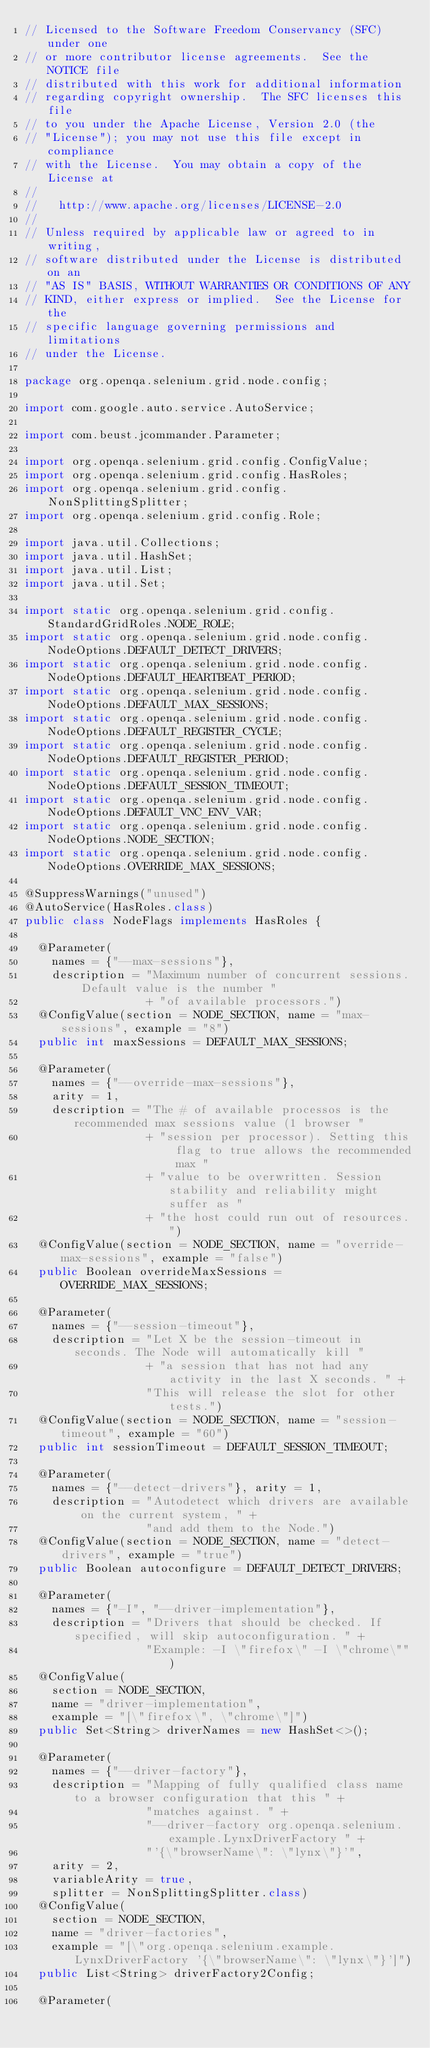Convert code to text. <code><loc_0><loc_0><loc_500><loc_500><_Java_>// Licensed to the Software Freedom Conservancy (SFC) under one
// or more contributor license agreements.  See the NOTICE file
// distributed with this work for additional information
// regarding copyright ownership.  The SFC licenses this file
// to you under the Apache License, Version 2.0 (the
// "License"); you may not use this file except in compliance
// with the License.  You may obtain a copy of the License at
//
//   http://www.apache.org/licenses/LICENSE-2.0
//
// Unless required by applicable law or agreed to in writing,
// software distributed under the License is distributed on an
// "AS IS" BASIS, WITHOUT WARRANTIES OR CONDITIONS OF ANY
// KIND, either express or implied.  See the License for the
// specific language governing permissions and limitations
// under the License.

package org.openqa.selenium.grid.node.config;

import com.google.auto.service.AutoService;

import com.beust.jcommander.Parameter;

import org.openqa.selenium.grid.config.ConfigValue;
import org.openqa.selenium.grid.config.HasRoles;
import org.openqa.selenium.grid.config.NonSplittingSplitter;
import org.openqa.selenium.grid.config.Role;

import java.util.Collections;
import java.util.HashSet;
import java.util.List;
import java.util.Set;

import static org.openqa.selenium.grid.config.StandardGridRoles.NODE_ROLE;
import static org.openqa.selenium.grid.node.config.NodeOptions.DEFAULT_DETECT_DRIVERS;
import static org.openqa.selenium.grid.node.config.NodeOptions.DEFAULT_HEARTBEAT_PERIOD;
import static org.openqa.selenium.grid.node.config.NodeOptions.DEFAULT_MAX_SESSIONS;
import static org.openqa.selenium.grid.node.config.NodeOptions.DEFAULT_REGISTER_CYCLE;
import static org.openqa.selenium.grid.node.config.NodeOptions.DEFAULT_REGISTER_PERIOD;
import static org.openqa.selenium.grid.node.config.NodeOptions.DEFAULT_SESSION_TIMEOUT;
import static org.openqa.selenium.grid.node.config.NodeOptions.DEFAULT_VNC_ENV_VAR;
import static org.openqa.selenium.grid.node.config.NodeOptions.NODE_SECTION;
import static org.openqa.selenium.grid.node.config.NodeOptions.OVERRIDE_MAX_SESSIONS;

@SuppressWarnings("unused")
@AutoService(HasRoles.class)
public class NodeFlags implements HasRoles {

  @Parameter(
    names = {"--max-sessions"},
    description = "Maximum number of concurrent sessions. Default value is the number "
                  + "of available processors.")
  @ConfigValue(section = NODE_SECTION, name = "max-sessions", example = "8")
  public int maxSessions = DEFAULT_MAX_SESSIONS;

  @Parameter(
    names = {"--override-max-sessions"},
    arity = 1,
    description = "The # of available processos is the recommended max sessions value (1 browser "
                  + "session per processor). Setting this flag to true allows the recommended max "
                  + "value to be overwritten. Session stability and reliability might suffer as "
                  + "the host could run out of resources.")
  @ConfigValue(section = NODE_SECTION, name = "override-max-sessions", example = "false")
  public Boolean overrideMaxSessions = OVERRIDE_MAX_SESSIONS;

  @Parameter(
    names = {"--session-timeout"},
    description = "Let X be the session-timeout in seconds. The Node will automatically kill "
                  + "a session that has not had any activity in the last X seconds. " +
                  "This will release the slot for other tests.")
  @ConfigValue(section = NODE_SECTION, name = "session-timeout", example = "60")
  public int sessionTimeout = DEFAULT_SESSION_TIMEOUT;

  @Parameter(
    names = {"--detect-drivers"}, arity = 1,
    description = "Autodetect which drivers are available on the current system, " +
                  "and add them to the Node.")
  @ConfigValue(section = NODE_SECTION, name = "detect-drivers", example = "true")
  public Boolean autoconfigure = DEFAULT_DETECT_DRIVERS;

  @Parameter(
    names = {"-I", "--driver-implementation"},
    description = "Drivers that should be checked. If specified, will skip autoconfiguration. " +
                  "Example: -I \"firefox\" -I \"chrome\"")
  @ConfigValue(
    section = NODE_SECTION,
    name = "driver-implementation",
    example = "[\"firefox\", \"chrome\"]")
  public Set<String> driverNames = new HashSet<>();

  @Parameter(
    names = {"--driver-factory"},
    description = "Mapping of fully qualified class name to a browser configuration that this " +
                  "matches against. " +
                  "--driver-factory org.openqa.selenium.example.LynxDriverFactory " +
                  "'{\"browserName\": \"lynx\"}'",
    arity = 2,
    variableArity = true,
    splitter = NonSplittingSplitter.class)
  @ConfigValue(
    section = NODE_SECTION,
    name = "driver-factories",
    example = "[\"org.openqa.selenium.example.LynxDriverFactory '{\"browserName\": \"lynx\"}']")
  public List<String> driverFactory2Config;

  @Parameter(</code> 